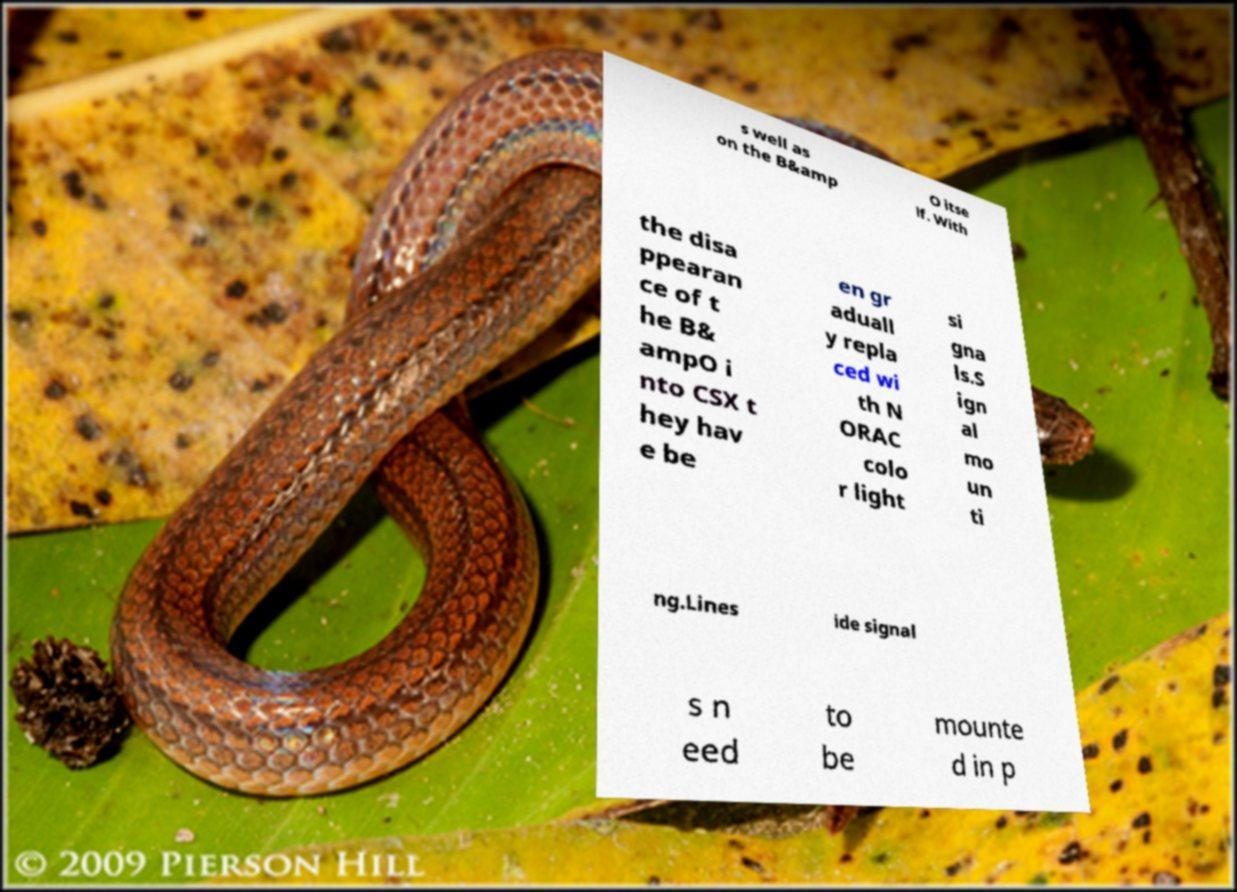Please read and relay the text visible in this image. What does it say? s well as on the B&amp O itse lf. With the disa ppearan ce of t he B& ampO i nto CSX t hey hav e be en gr aduall y repla ced wi th N ORAC colo r light si gna ls.S ign al mo un ti ng.Lines ide signal s n eed to be mounte d in p 